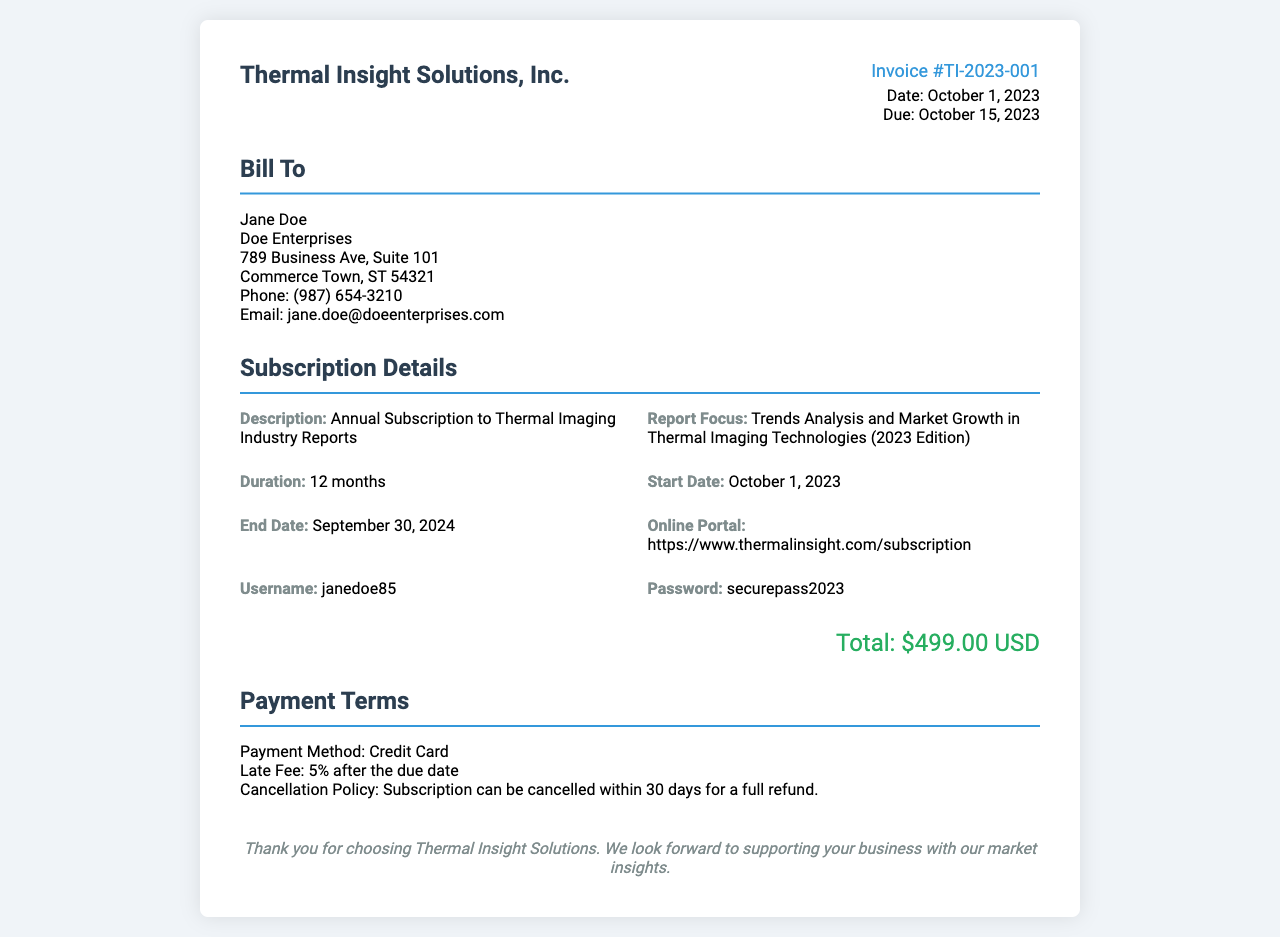What is the invoice number? The invoice number is prominently displayed in the document, labeled as Invoice #TI-2023-001.
Answer: Invoice #TI-2023-001 What is the total amount due? The total amount due is stated clearly at the bottom of the subscription details section as $499.00 USD.
Answer: $499.00 USD Who is the recipient of this invoice? The recipient's name is located in the "Bill To" section, specifically Jane Doe.
Answer: Jane Doe What is the subscription duration? The duration is mentioned in the subscription details, indicating that it lasts for 12 months.
Answer: 12 months When does the subscription end? The end date is provided under the subscription details section, which states it is September 30, 2024.
Answer: September 30, 2024 What is the payment method indicated in the document? The payment method is explicitly mentioned in the payment terms section, which states Credit Card.
Answer: Credit Card What is the cancellation policy? The cancellation policy can be found in the payment terms section, highlighting that it can be cancelled within 30 days for a full refund.
Answer: Subscription can be cancelled within 30 days for a full refund When was the invoice issued? The issue date is noted in the invoice details section as October 1, 2023.
Answer: October 1, 2023 What is the online portal for accessing reports? The online portal link is specified in the subscription details and can be found as https://www.thermalinsight.com/subscription.
Answer: https://www.thermalinsight.com/subscription 